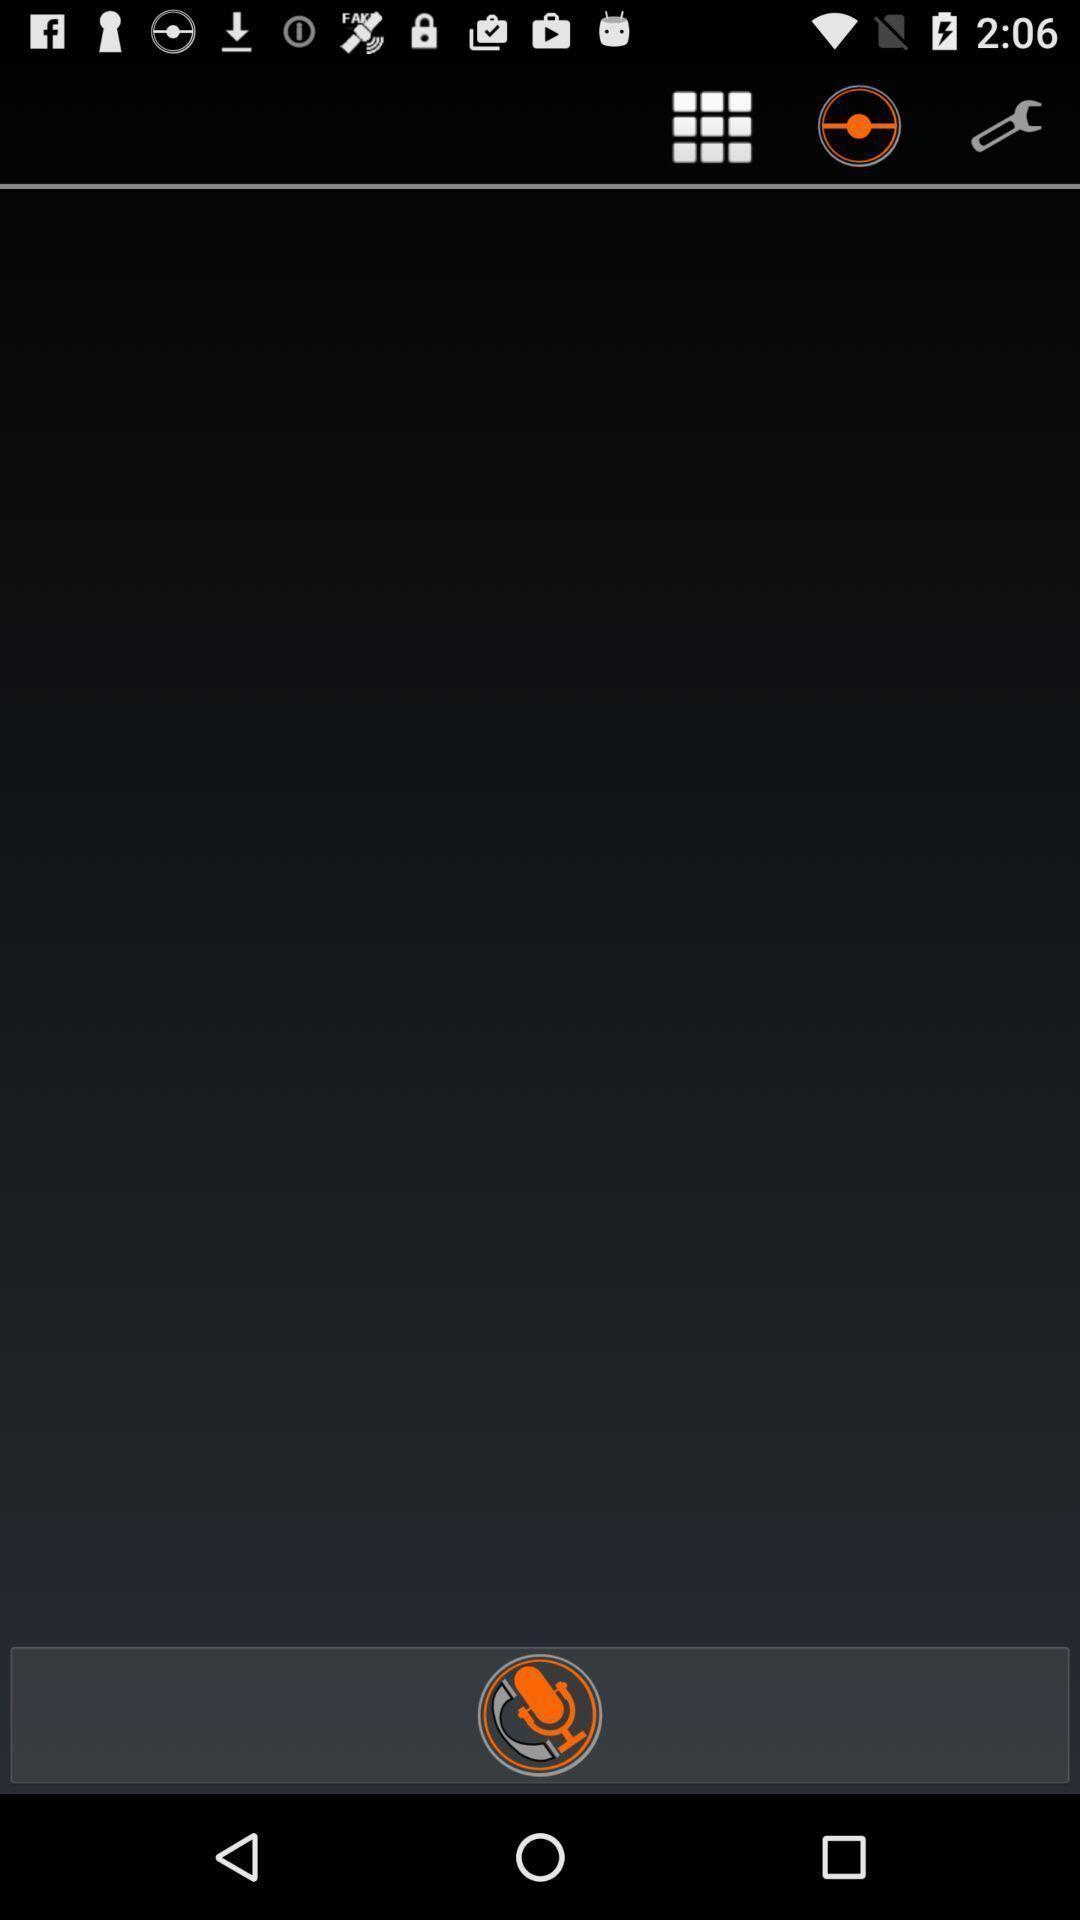Explain what's happening in this screen capture. Voice button in a voice recorder app. 